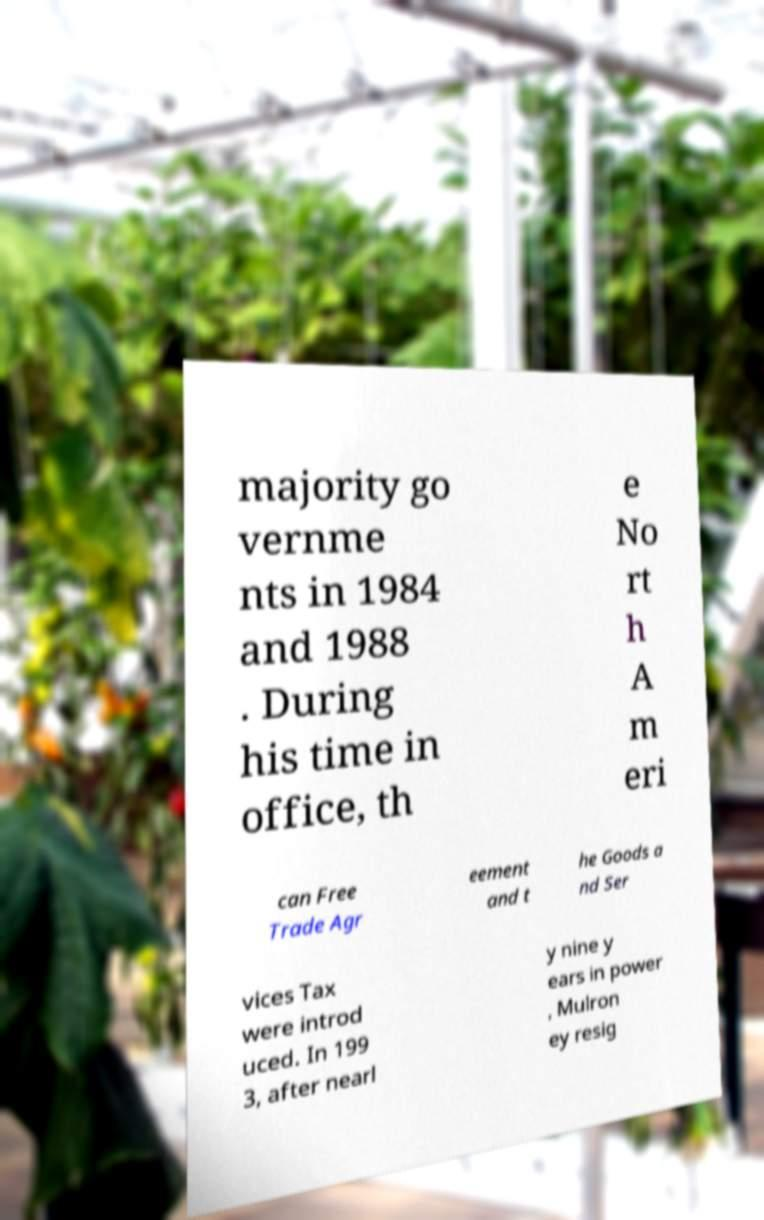I need the written content from this picture converted into text. Can you do that? majority go vernme nts in 1984 and 1988 . During his time in office, th e No rt h A m eri can Free Trade Agr eement and t he Goods a nd Ser vices Tax were introd uced. In 199 3, after nearl y nine y ears in power , Mulron ey resig 